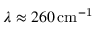Convert formula to latex. <formula><loc_0><loc_0><loc_500><loc_500>\lambda \approx 2 6 0 \, c m ^ { - 1 }</formula> 